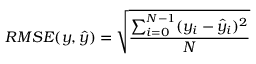<formula> <loc_0><loc_0><loc_500><loc_500>{ R M S E } ( y , \hat { y } ) = \sqrt { \frac { \sum _ { i = 0 } ^ { N - 1 } ( y _ { i } - \hat { y } _ { i } ) ^ { 2 } } { N } }</formula> 